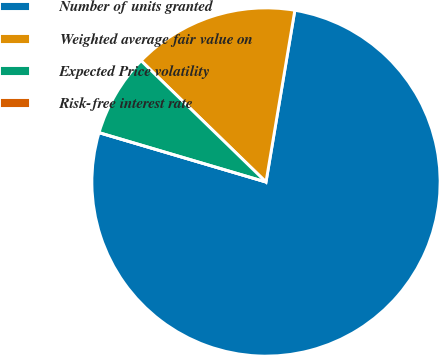Convert chart to OTSL. <chart><loc_0><loc_0><loc_500><loc_500><pie_chart><fcel>Number of units granted<fcel>Weighted average fair value on<fcel>Expected Price volatility<fcel>Risk-free interest rate<nl><fcel>76.92%<fcel>15.38%<fcel>7.69%<fcel>0.0%<nl></chart> 